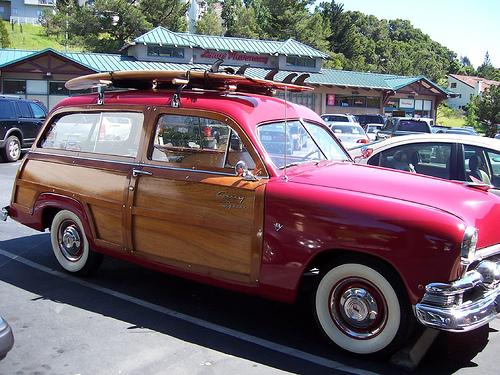Is this a car one solid color?
Give a very brief answer. No. What are the sides of the car made out of?
Short answer required. Wood. What is on top of the car?
Be succinct. Surfboard. What type of vehicle is in the image?
Answer briefly. Car. What color is this truck near the surfboard?
Quick response, please. Red. What color is the surfboard?
Write a very short answer. Brown. What type of car is shown?
Keep it brief. Station wagon. 